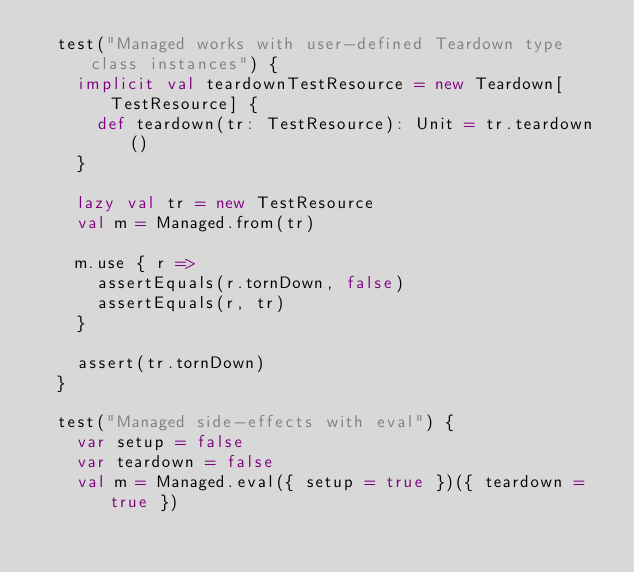<code> <loc_0><loc_0><loc_500><loc_500><_Scala_>  test("Managed works with user-defined Teardown type class instances") {
    implicit val teardownTestResource = new Teardown[TestResource] {
      def teardown(tr: TestResource): Unit = tr.teardown()
    }

    lazy val tr = new TestResource
    val m = Managed.from(tr)

    m.use { r =>
      assertEquals(r.tornDown, false)
      assertEquals(r, tr)
    }

    assert(tr.tornDown)
  }

  test("Managed side-effects with eval") {
    var setup = false
    var teardown = false
    val m = Managed.eval({ setup = true })({ teardown = true })
</code> 